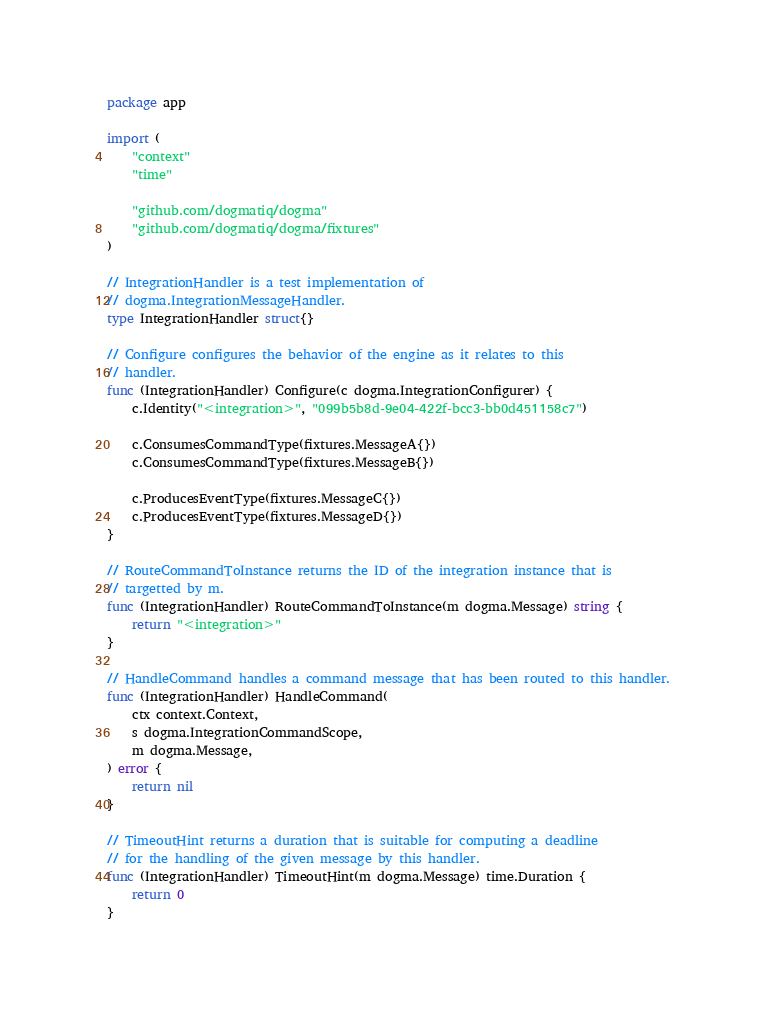<code> <loc_0><loc_0><loc_500><loc_500><_Go_>package app

import (
	"context"
	"time"

	"github.com/dogmatiq/dogma"
	"github.com/dogmatiq/dogma/fixtures"
)

// IntegrationHandler is a test implementation of
// dogma.IntegrationMessageHandler.
type IntegrationHandler struct{}

// Configure configures the behavior of the engine as it relates to this
// handler.
func (IntegrationHandler) Configure(c dogma.IntegrationConfigurer) {
	c.Identity("<integration>", "099b5b8d-9e04-422f-bcc3-bb0d451158c7")

	c.ConsumesCommandType(fixtures.MessageA{})
	c.ConsumesCommandType(fixtures.MessageB{})

	c.ProducesEventType(fixtures.MessageC{})
	c.ProducesEventType(fixtures.MessageD{})
}

// RouteCommandToInstance returns the ID of the integration instance that is
// targetted by m.
func (IntegrationHandler) RouteCommandToInstance(m dogma.Message) string {
	return "<integration>"
}

// HandleCommand handles a command message that has been routed to this handler.
func (IntegrationHandler) HandleCommand(
	ctx context.Context,
	s dogma.IntegrationCommandScope,
	m dogma.Message,
) error {
	return nil
}

// TimeoutHint returns a duration that is suitable for computing a deadline
// for the handling of the given message by this handler.
func (IntegrationHandler) TimeoutHint(m dogma.Message) time.Duration {
	return 0
}
</code> 